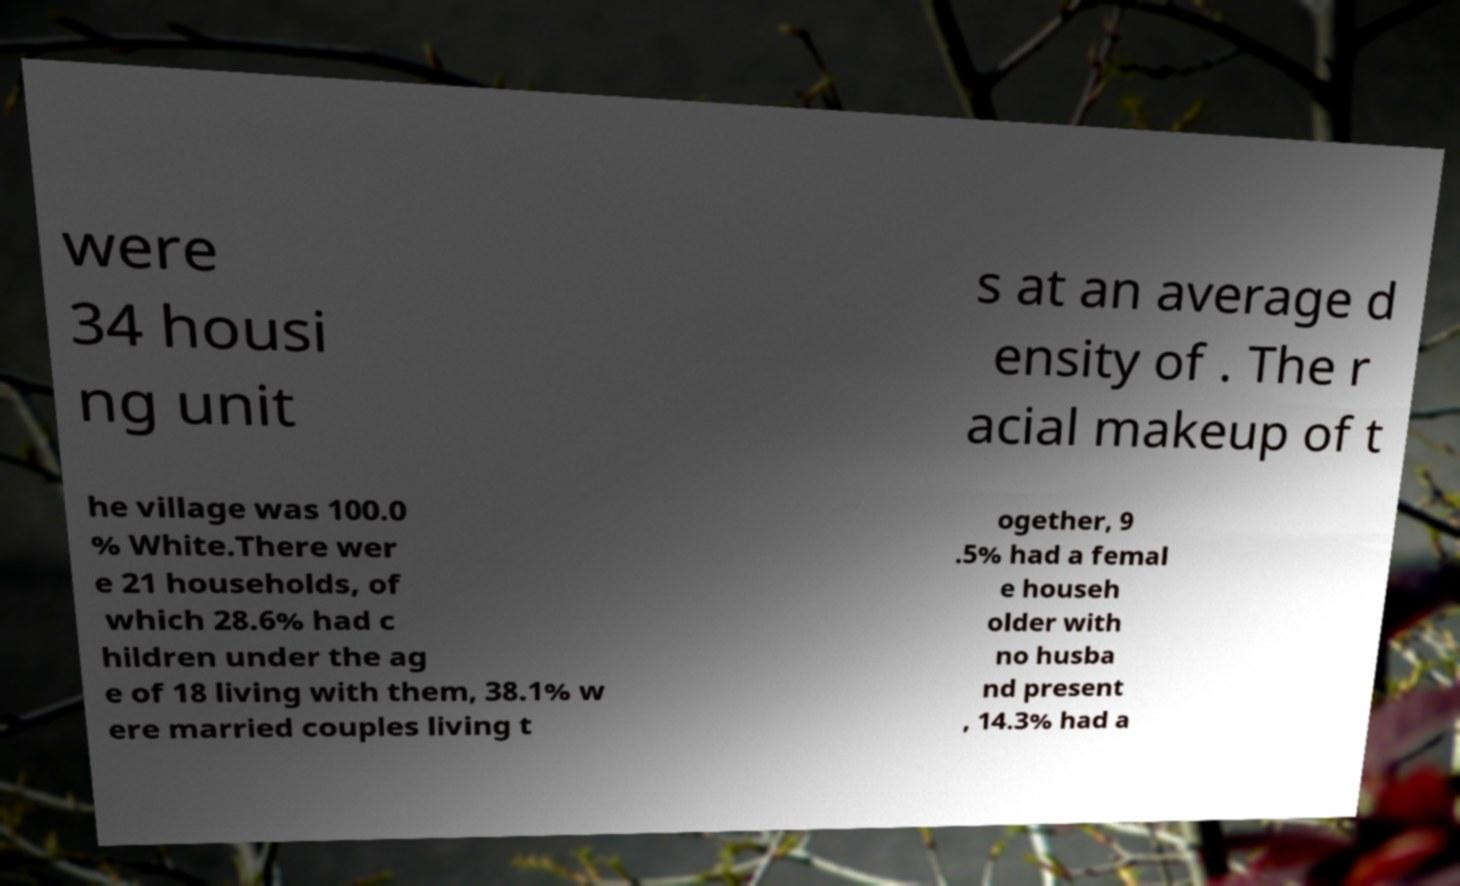For documentation purposes, I need the text within this image transcribed. Could you provide that? were 34 housi ng unit s at an average d ensity of . The r acial makeup of t he village was 100.0 % White.There wer e 21 households, of which 28.6% had c hildren under the ag e of 18 living with them, 38.1% w ere married couples living t ogether, 9 .5% had a femal e househ older with no husba nd present , 14.3% had a 